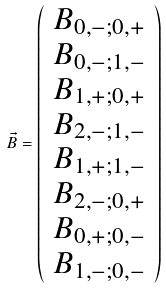Convert formula to latex. <formula><loc_0><loc_0><loc_500><loc_500>\vec { B } = \left ( \begin{array} { c } B _ { 0 , - ; 0 , + } \\ B _ { 0 , - ; 1 , - } \\ B _ { 1 , + ; 0 , + } \\ B _ { 2 , - ; 1 , - } \\ B _ { 1 , + ; 1 , - } \\ B _ { 2 , - ; 0 , + } \\ B _ { 0 , + ; 0 , - } \\ B _ { 1 , - ; 0 , - } \end{array} \right )</formula> 